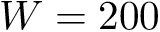Convert formula to latex. <formula><loc_0><loc_0><loc_500><loc_500>W = 2 0 0</formula> 